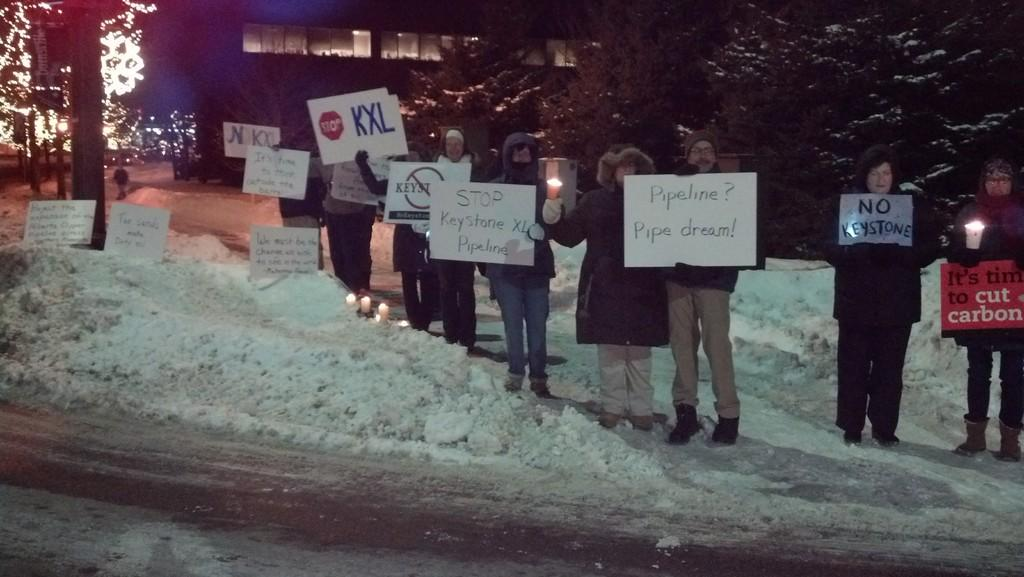What are the people in the image holding? The people in the image are holding boards and lamps. What is on the snow in the image? There are boards on the snow. What can be seen in the background of the image? There are trees, a building, and lights visible in the background. How are the people sorting the tails in the image? There are no tails present in the image; the people are holding boards and lamps. What type of star can be seen in the image? There is no star visible in the image; the background features trees, a building, and lights. 